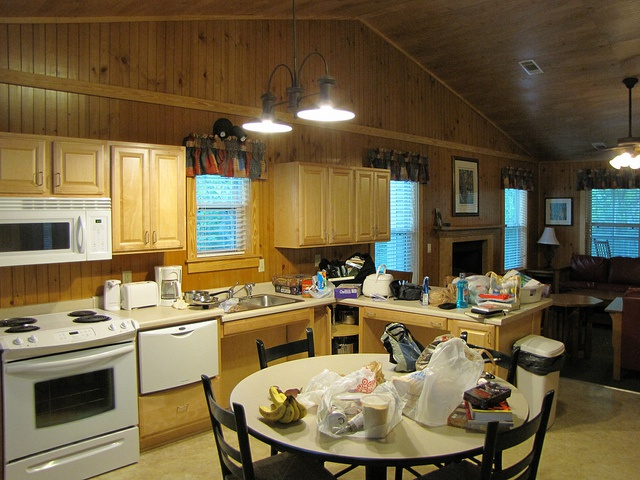Describe the objects in this image and their specific colors. I can see dining table in maroon, tan, and black tones, oven in maroon, gray, darkgray, and black tones, microwave in maroon, beige, black, and darkgray tones, chair in maroon, black, olive, tan, and gray tones, and chair in maroon, black, and olive tones in this image. 